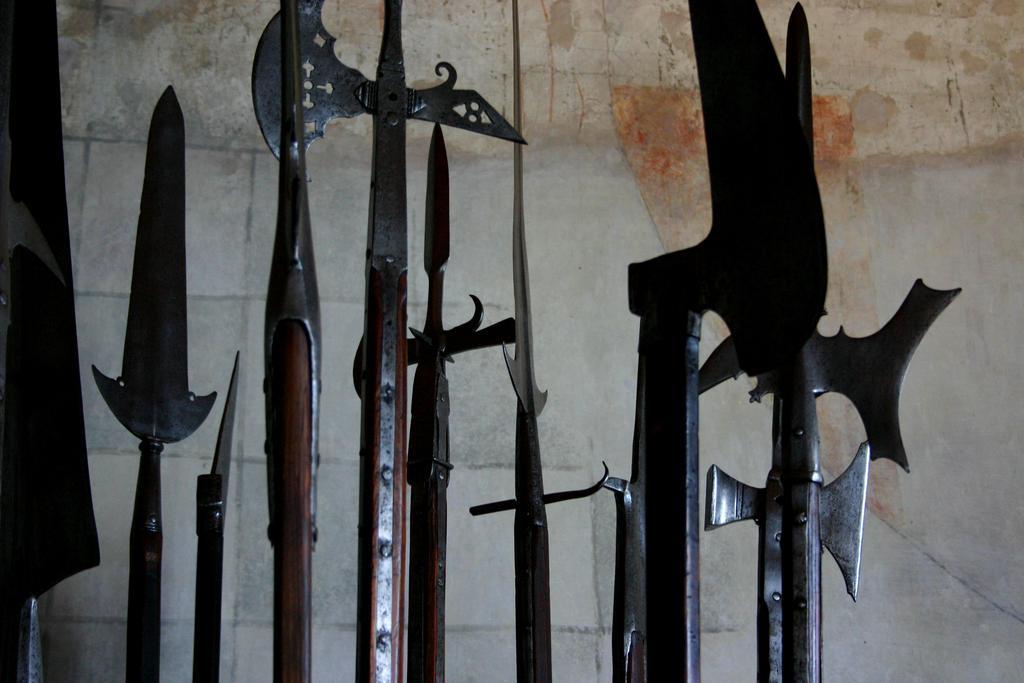Can you describe this image briefly? In the picture I can see some weapons here and in the background, I can see the stone wall. 